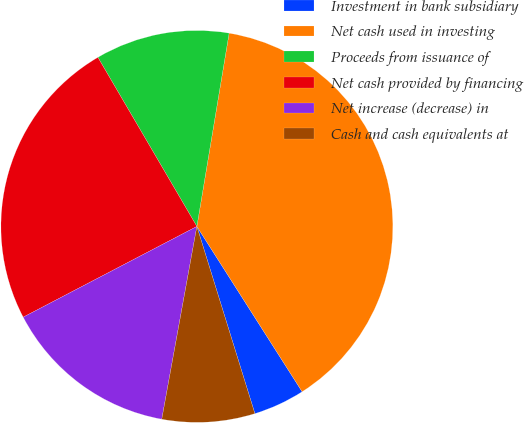Convert chart to OTSL. <chart><loc_0><loc_0><loc_500><loc_500><pie_chart><fcel>Investment in bank subsidiary<fcel>Net cash used in investing<fcel>Proceeds from issuance of<fcel>Net cash provided by financing<fcel>Net increase (decrease) in<fcel>Cash and cash equivalents at<nl><fcel>4.24%<fcel>38.34%<fcel>11.06%<fcel>24.23%<fcel>14.47%<fcel>7.65%<nl></chart> 